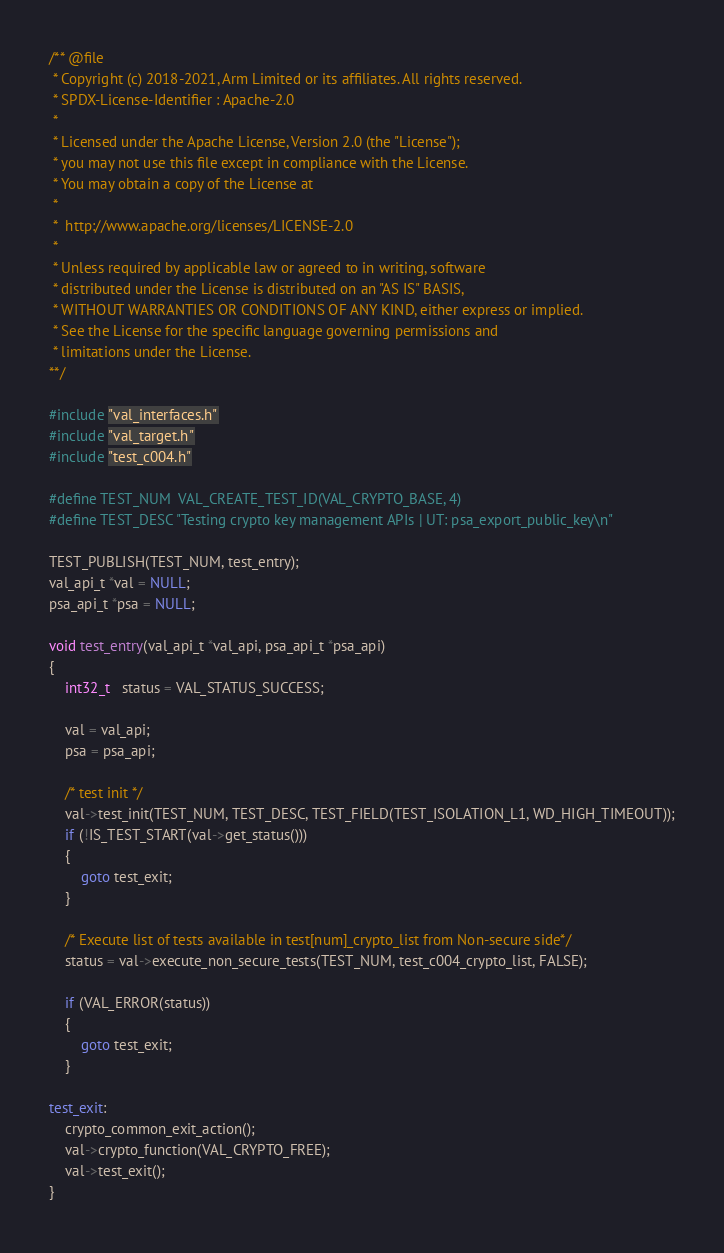<code> <loc_0><loc_0><loc_500><loc_500><_C_>/** @file
 * Copyright (c) 2018-2021, Arm Limited or its affiliates. All rights reserved.
 * SPDX-License-Identifier : Apache-2.0
 *
 * Licensed under the Apache License, Version 2.0 (the "License");
 * you may not use this file except in compliance with the License.
 * You may obtain a copy of the License at
 *
 *  http://www.apache.org/licenses/LICENSE-2.0
 *
 * Unless required by applicable law or agreed to in writing, software
 * distributed under the License is distributed on an "AS IS" BASIS,
 * WITHOUT WARRANTIES OR CONDITIONS OF ANY KIND, either express or implied.
 * See the License for the specific language governing permissions and
 * limitations under the License.
**/

#include "val_interfaces.h"
#include "val_target.h"
#include "test_c004.h"

#define TEST_NUM  VAL_CREATE_TEST_ID(VAL_CRYPTO_BASE, 4)
#define TEST_DESC "Testing crypto key management APIs | UT: psa_export_public_key\n"

TEST_PUBLISH(TEST_NUM, test_entry);
val_api_t *val = NULL;
psa_api_t *psa = NULL;

void test_entry(val_api_t *val_api, psa_api_t *psa_api)
{
    int32_t   status = VAL_STATUS_SUCCESS;

    val = val_api;
    psa = psa_api;

    /* test init */
    val->test_init(TEST_NUM, TEST_DESC, TEST_FIELD(TEST_ISOLATION_L1, WD_HIGH_TIMEOUT));
    if (!IS_TEST_START(val->get_status()))
    {
        goto test_exit;
    }

    /* Execute list of tests available in test[num]_crypto_list from Non-secure side*/
    status = val->execute_non_secure_tests(TEST_NUM, test_c004_crypto_list, FALSE);

    if (VAL_ERROR(status))
    {
        goto test_exit;
    }

test_exit:
    crypto_common_exit_action();
    val->crypto_function(VAL_CRYPTO_FREE);
    val->test_exit();
}
</code> 